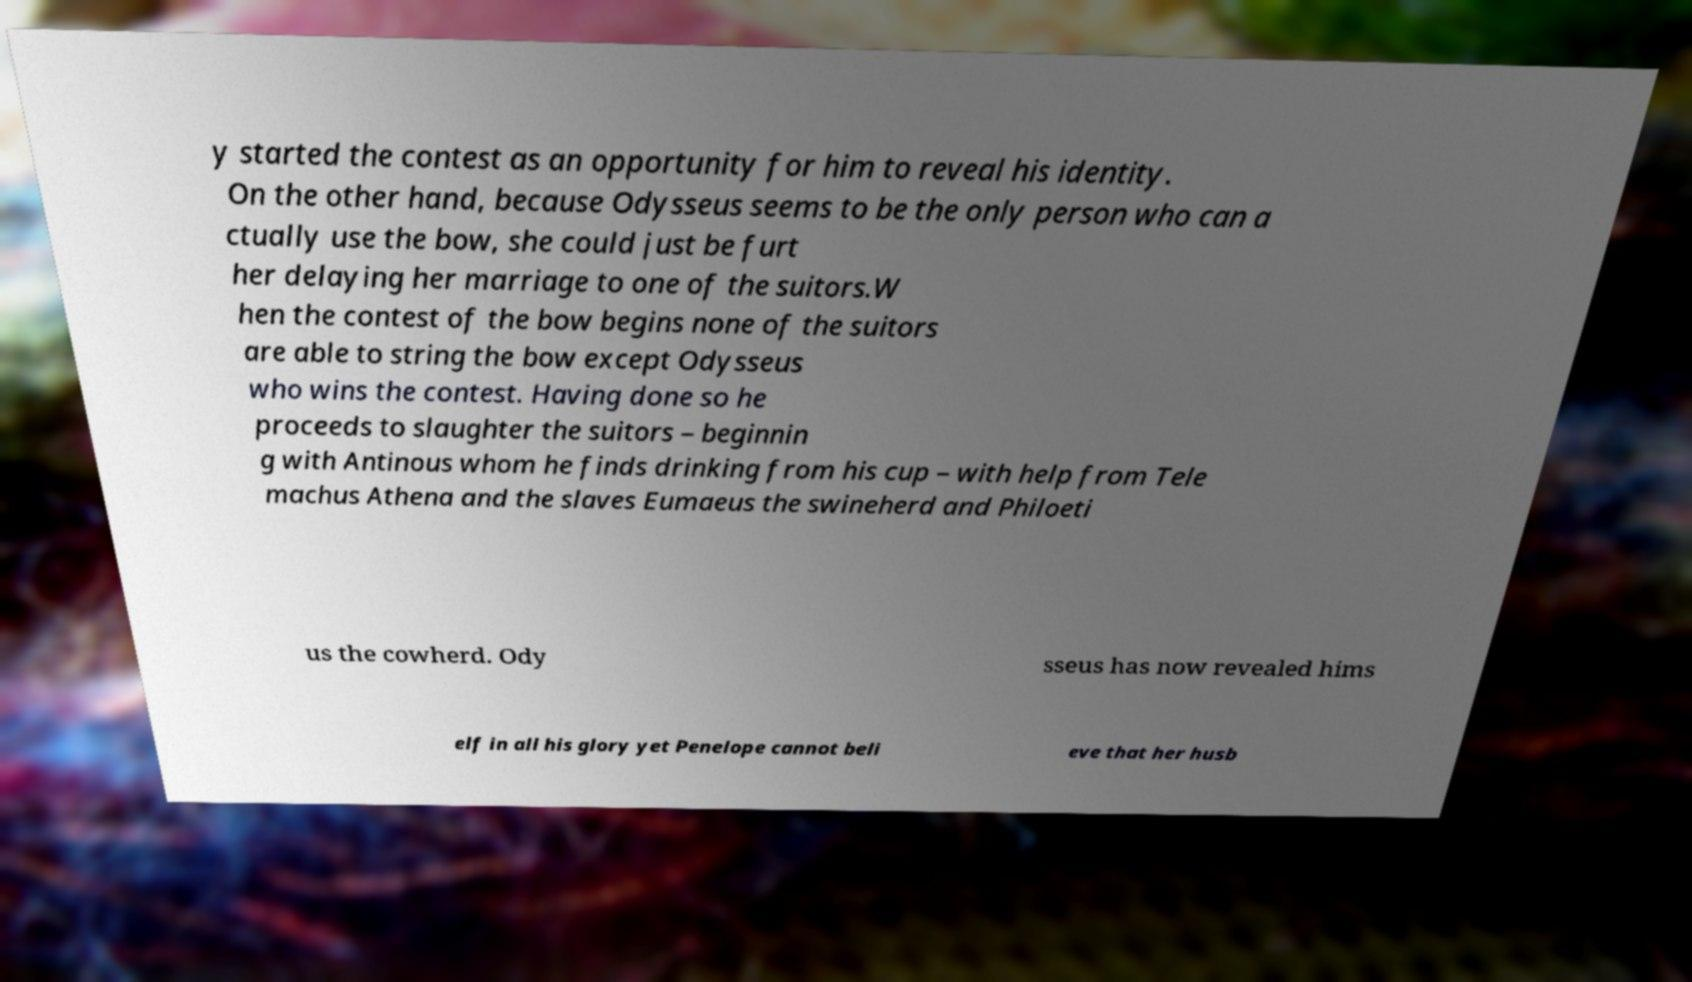Could you assist in decoding the text presented in this image and type it out clearly? y started the contest as an opportunity for him to reveal his identity. On the other hand, because Odysseus seems to be the only person who can a ctually use the bow, she could just be furt her delaying her marriage to one of the suitors.W hen the contest of the bow begins none of the suitors are able to string the bow except Odysseus who wins the contest. Having done so he proceeds to slaughter the suitors – beginnin g with Antinous whom he finds drinking from his cup – with help from Tele machus Athena and the slaves Eumaeus the swineherd and Philoeti us the cowherd. Ody sseus has now revealed hims elf in all his glory yet Penelope cannot beli eve that her husb 